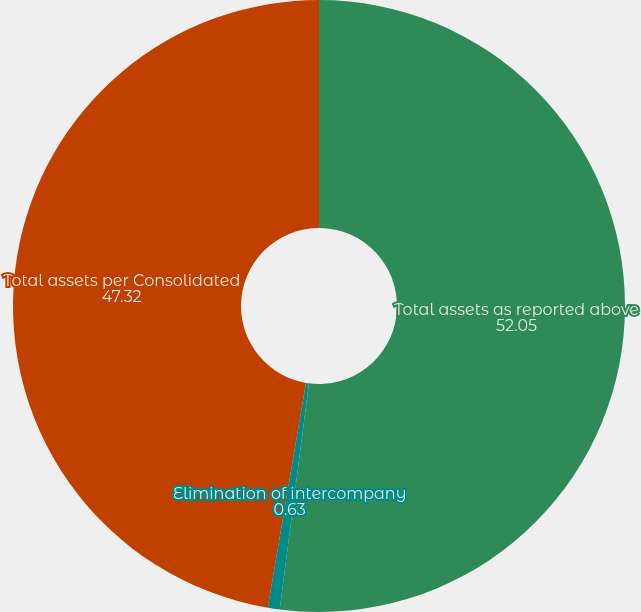<chart> <loc_0><loc_0><loc_500><loc_500><pie_chart><fcel>Total assets as reported above<fcel>Elimination of intercompany<fcel>Total assets per Consolidated<nl><fcel>52.05%<fcel>0.63%<fcel>47.32%<nl></chart> 